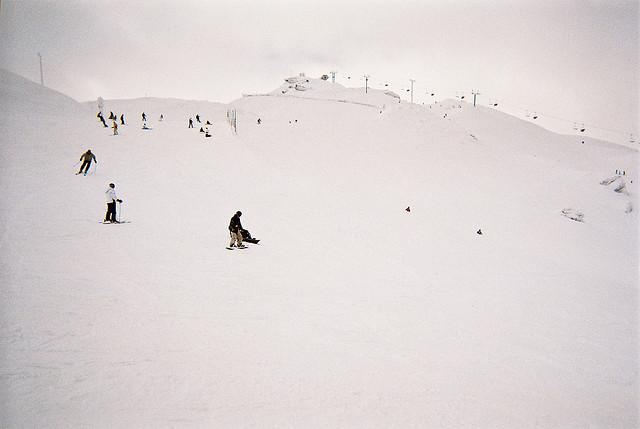What kind of sport are the people pictured above playing? skiing 